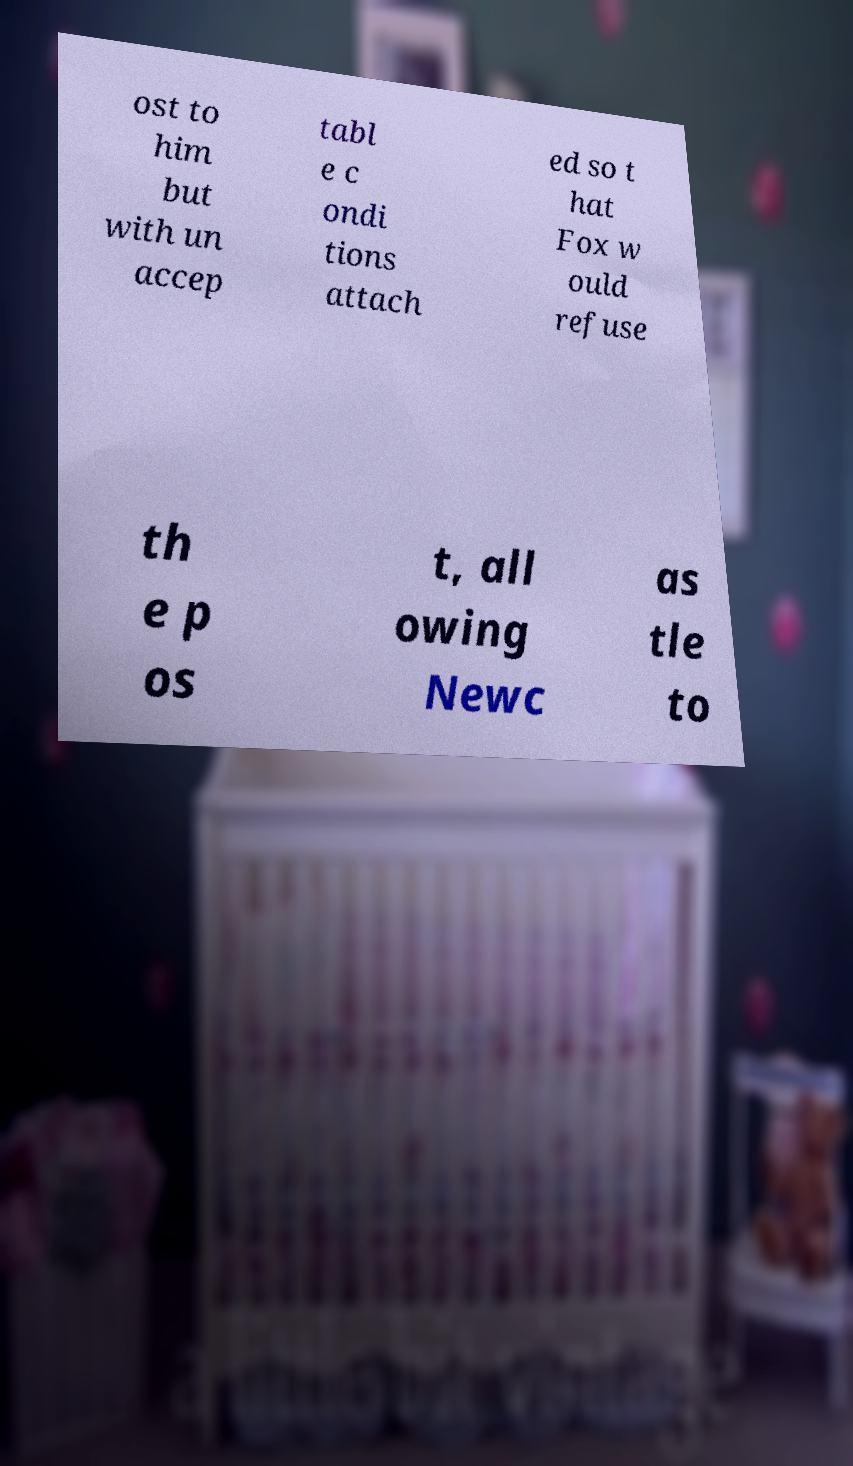I need the written content from this picture converted into text. Can you do that? ost to him but with un accep tabl e c ondi tions attach ed so t hat Fox w ould refuse th e p os t, all owing Newc as tle to 